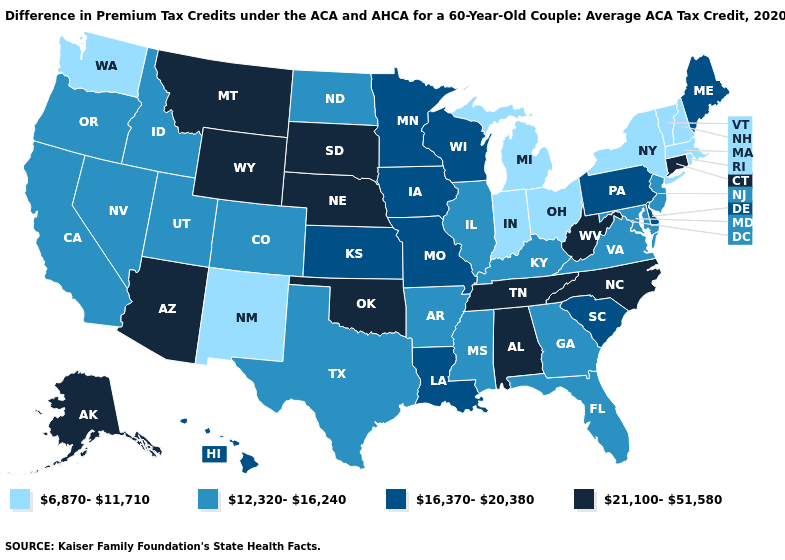Does New Hampshire have the lowest value in the USA?
Write a very short answer. Yes. Name the states that have a value in the range 6,870-11,710?
Be succinct. Indiana, Massachusetts, Michigan, New Hampshire, New Mexico, New York, Ohio, Rhode Island, Vermont, Washington. What is the value of Washington?
Give a very brief answer. 6,870-11,710. What is the lowest value in states that border Ohio?
Concise answer only. 6,870-11,710. Name the states that have a value in the range 12,320-16,240?
Write a very short answer. Arkansas, California, Colorado, Florida, Georgia, Idaho, Illinois, Kentucky, Maryland, Mississippi, Nevada, New Jersey, North Dakota, Oregon, Texas, Utah, Virginia. What is the value of Idaho?
Keep it brief. 12,320-16,240. What is the value of Oklahoma?
Be succinct. 21,100-51,580. Is the legend a continuous bar?
Be succinct. No. What is the value of Delaware?
Write a very short answer. 16,370-20,380. Among the states that border Massachusetts , does Connecticut have the lowest value?
Be succinct. No. Name the states that have a value in the range 12,320-16,240?
Quick response, please. Arkansas, California, Colorado, Florida, Georgia, Idaho, Illinois, Kentucky, Maryland, Mississippi, Nevada, New Jersey, North Dakota, Oregon, Texas, Utah, Virginia. Does West Virginia have the same value as Wisconsin?
Write a very short answer. No. Does South Dakota have the highest value in the MidWest?
Write a very short answer. Yes. How many symbols are there in the legend?
Be succinct. 4. Name the states that have a value in the range 12,320-16,240?
Keep it brief. Arkansas, California, Colorado, Florida, Georgia, Idaho, Illinois, Kentucky, Maryland, Mississippi, Nevada, New Jersey, North Dakota, Oregon, Texas, Utah, Virginia. 